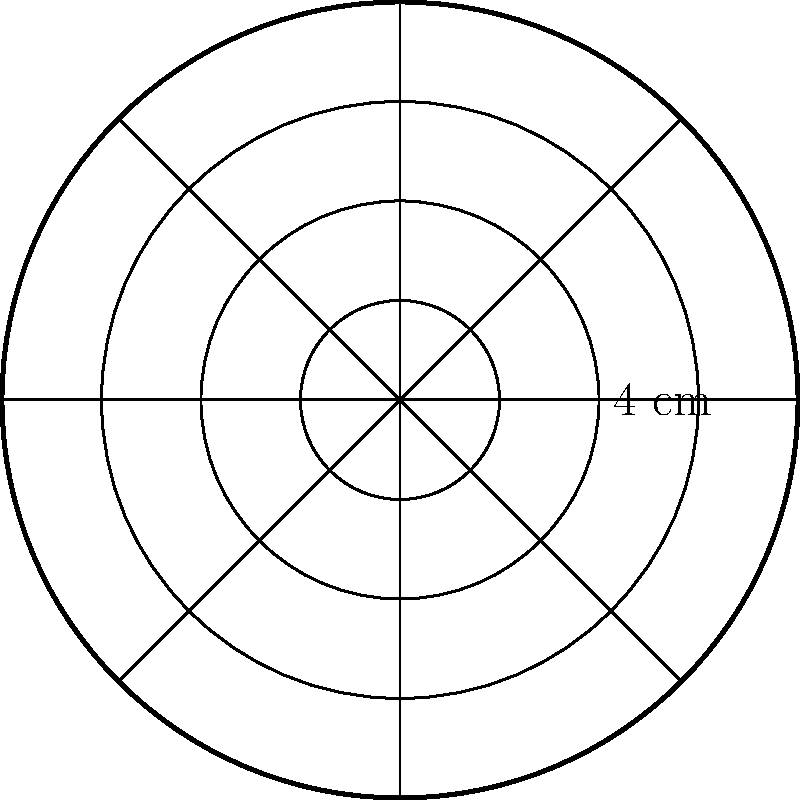A beautiful mandala-inspired circular design is created for a spiritual meditation session. The design consists of a large circle with intricate patterns inside, as shown in the diagram. If the radius of the outermost circle is 4 cm, what is the total area of the mandala design? To find the area of the mandala design, we need to calculate the area of the outermost circle. The formula for the area of a circle is $A = \pi r^2$, where $r$ is the radius.

Given:
- The radius of the outermost circle is 4 cm

Step 1: Substitute the radius into the formula
$A = \pi (4 \text{ cm})^2$

Step 2: Simplify the expression
$A = \pi (16 \text{ cm}^2)$

Step 3: Calculate the final result
$A = 16\pi \text{ cm}^2$

Note: We leave the answer in terms of $\pi$ for precision, as it's common in mathematical contexts. However, if a decimal approximation is required, we can use $\pi \approx 3.14159$, which would give us approximately 50.27 cm².
Answer: $16\pi \text{ cm}^2$ 